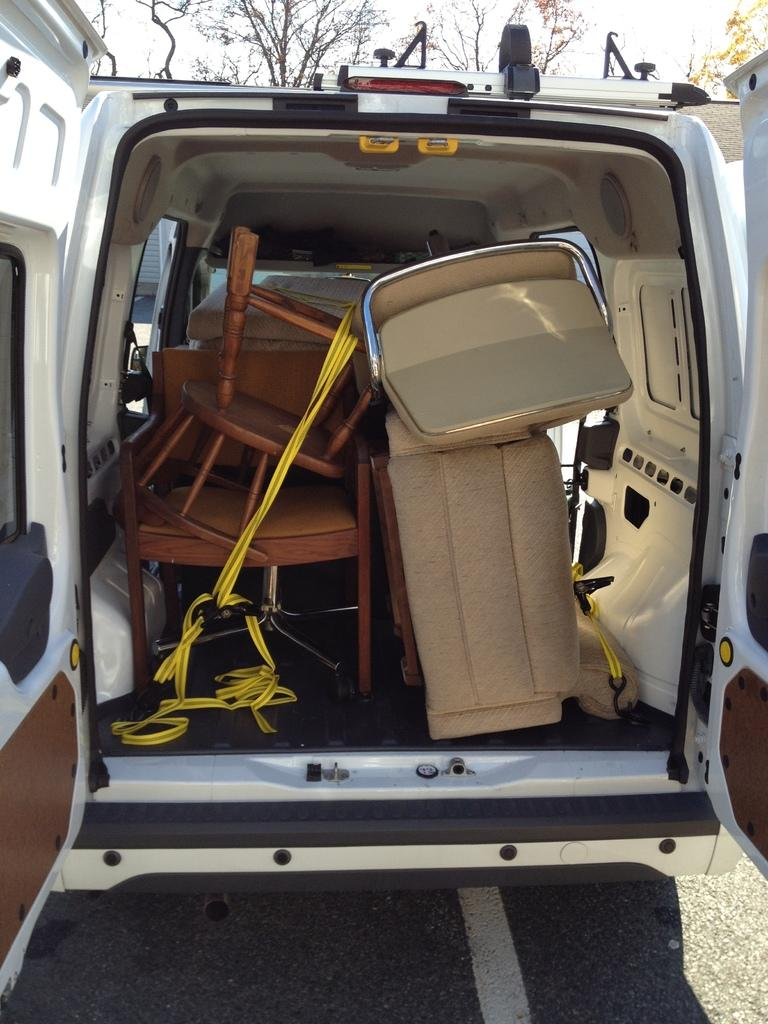What is the main subject of the image? There is a vehicle in the image. What is the state of the vehicle's back door? The back door of the vehicle is opened. What can be seen inside the vehicle? There are furniture pieces inside the vehicle. What is visible in the background of the image? There are trees behind the vehicle. What type of jewel can be seen sparkling on the vehicle's hood in the image? There is no jewel present on the vehicle's hood in the image. What smell is emanating from the vehicle in the image? There is no information about any smell in the image. 